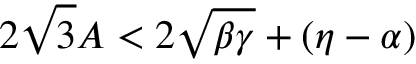<formula> <loc_0><loc_0><loc_500><loc_500>2 \sqrt { 3 } A < 2 \sqrt { \beta \gamma } + ( \eta - \alpha )</formula> 